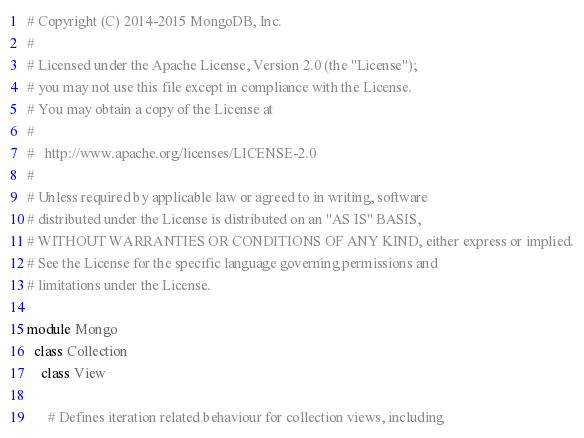Convert code to text. <code><loc_0><loc_0><loc_500><loc_500><_Ruby_># Copyright (C) 2014-2015 MongoDB, Inc.
#
# Licensed under the Apache License, Version 2.0 (the "License");
# you may not use this file except in compliance with the License.
# You may obtain a copy of the License at
#
#   http://www.apache.org/licenses/LICENSE-2.0
#
# Unless required by applicable law or agreed to in writing, software
# distributed under the License is distributed on an "AS IS" BASIS,
# WITHOUT WARRANTIES OR CONDITIONS OF ANY KIND, either express or implied.
# See the License for the specific language governing permissions and
# limitations under the License.

module Mongo
  class Collection
    class View

      # Defines iteration related behaviour for collection views, including</code> 